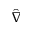Convert formula to latex. <formula><loc_0><loc_0><loc_500><loc_500>\hat { \nabla }</formula> 